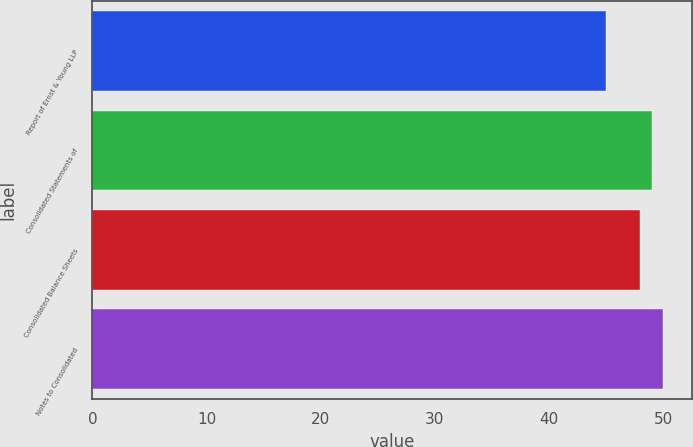<chart> <loc_0><loc_0><loc_500><loc_500><bar_chart><fcel>Report of Ernst & Young LLP<fcel>Consolidated Statements of<fcel>Consolidated Balance Sheets<fcel>Notes to Consolidated<nl><fcel>45<fcel>49<fcel>48<fcel>50<nl></chart> 